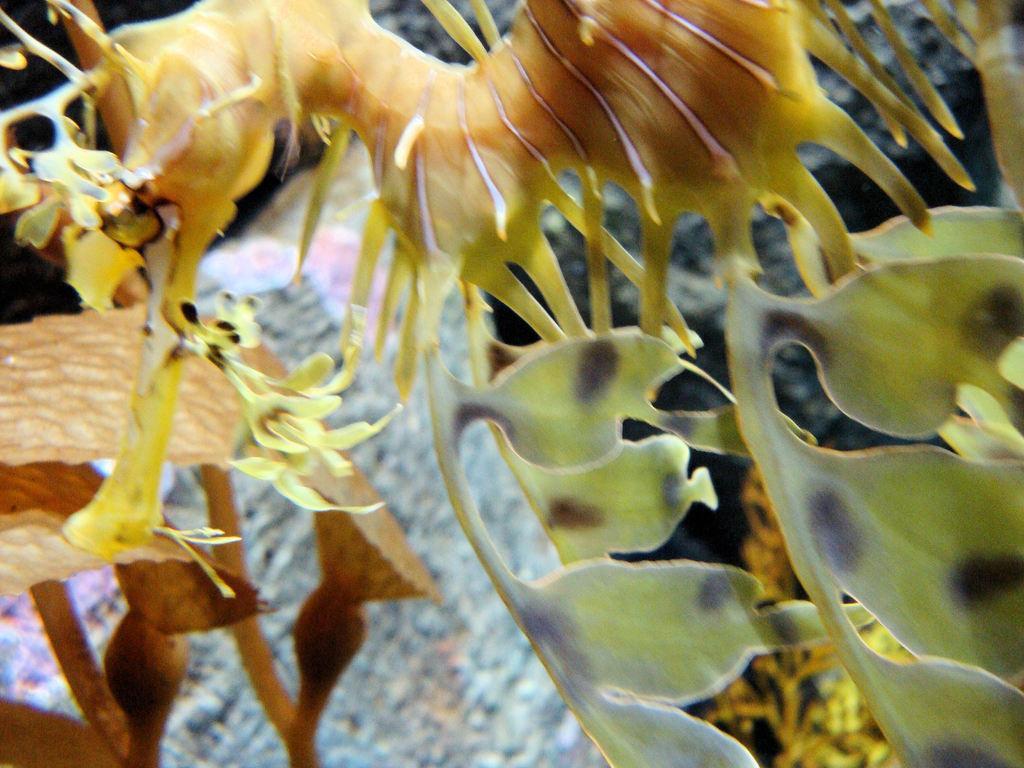In one or two sentences, can you explain what this image depicts? In this image we can see planets and objects. 